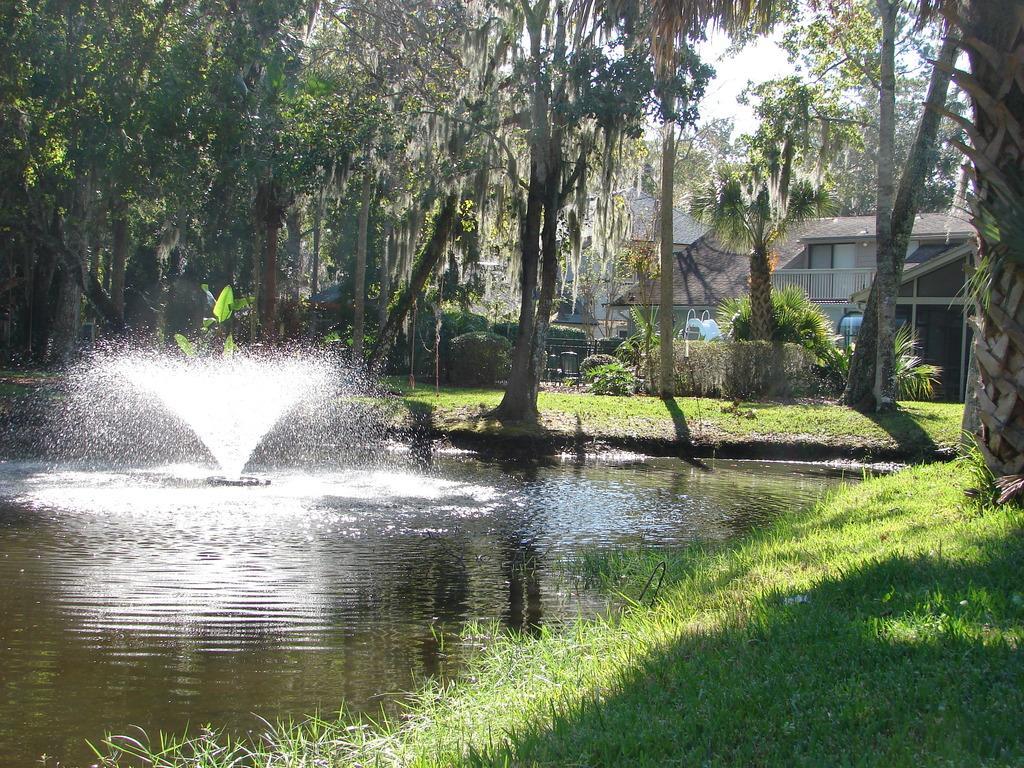Can you describe this image briefly? In this image there is a sprinkler in the water, around the water there is grass on the surface and there are trees, in the background of the image there are trees. 